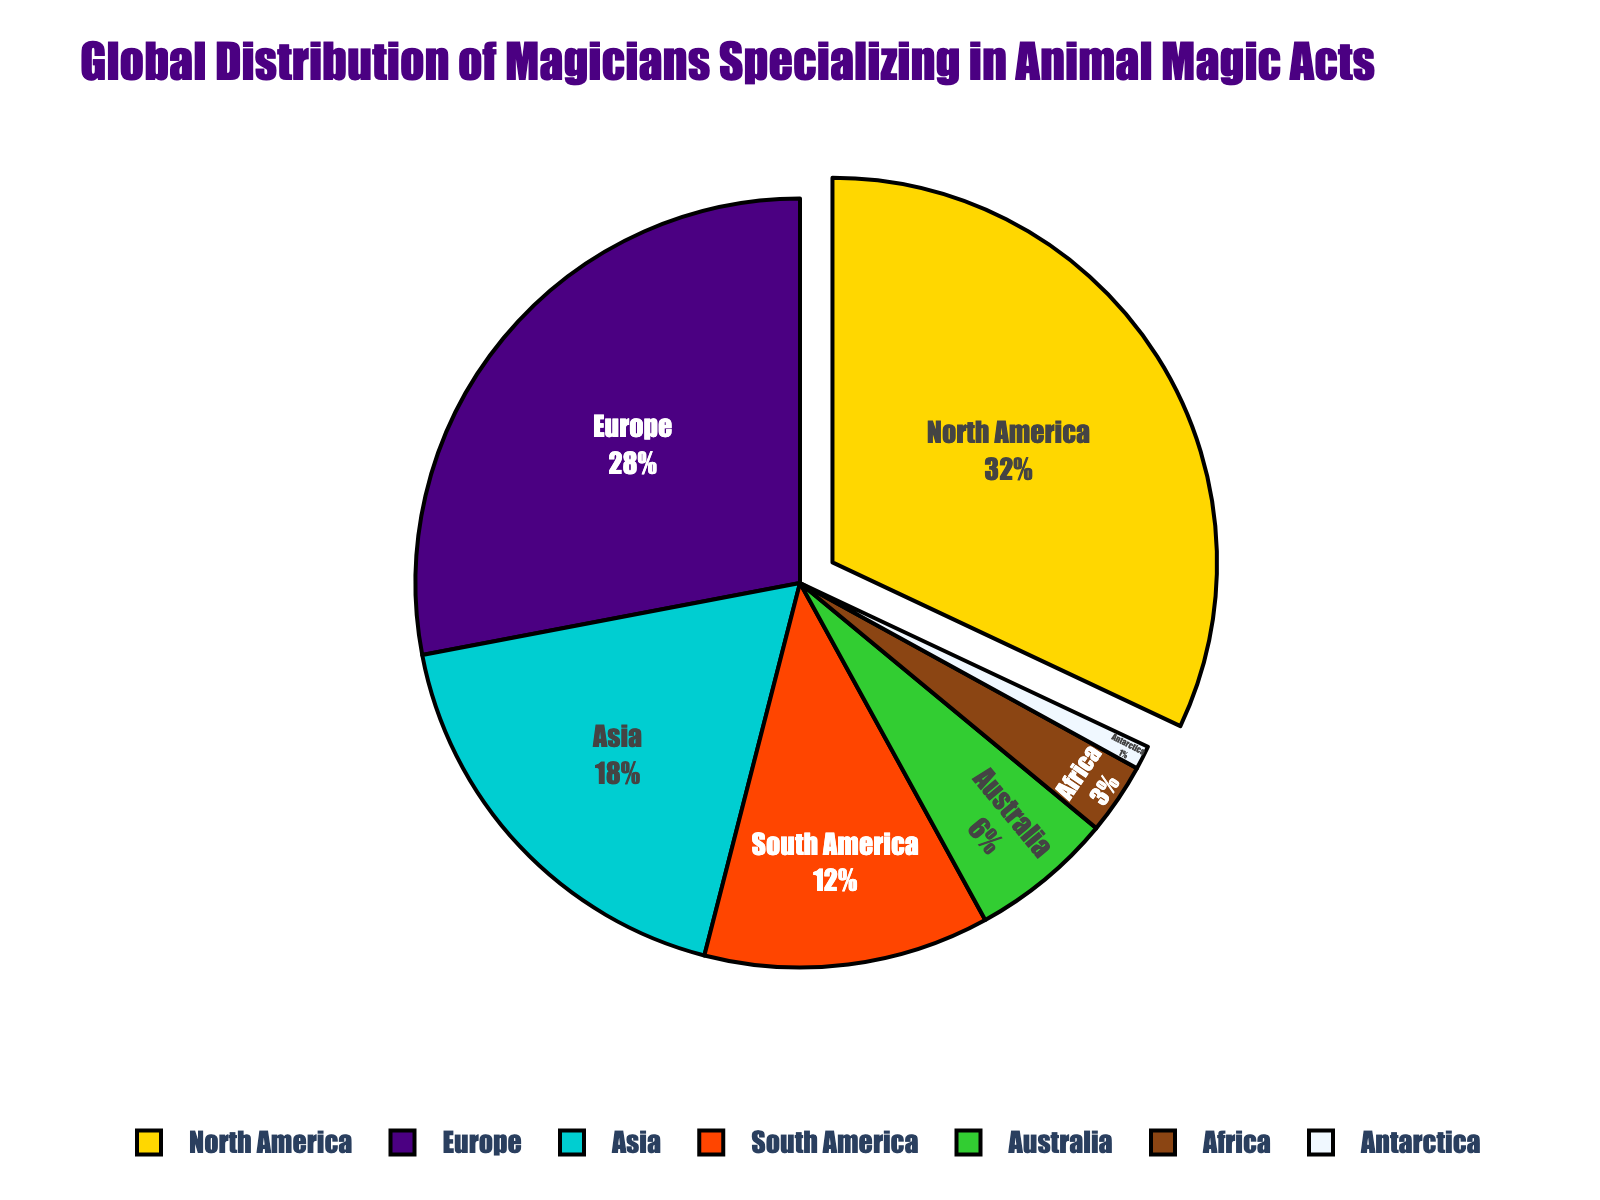Which continent has the highest percentage of magicians specializing in animal magic acts? According to the pie chart, the largest slice corresponds to North America.
Answer: North America What is the combined percentage of magicians specializing in animal magic acts in North America and Europe? To find the combined percentage, add the percentages of North America and Europe: 32% + 28% = 60%.
Answer: 60% Which continents together account for exactly half of the global distribution? We need to find a combination of continents that sum up to 50%. South America (12%) + Asia (18%) + Australia (6%) + Africa (3%) + Antarctica (1%) = 40%, so try another combination. Asia (18%) + Europe (28%) + Antarctica (1%) + Africa (3%) = 50%.
Answer: Asia and Europe What is the percentage difference between Asia and South America in terms of magicians specializing in animal magic acts? Subtract the percentage of South America from that of Asia: 18% - 12% = 6%.
Answer: 6% Identify the continent with the smallest representation of magicians specializing in animal magic acts. The smallest slice on the pie chart represents Antarctica.
Answer: Antarctica How much larger is the percentage of magicians in North America compared to those in Australia? Subtract the percentage of Australia from North America's percentage: 32% - 6% = 26%.
Answer: 26% What percentage of the global distribution is covered by continents with more than 20% representation? Only North America (32%) and Europe (28%) have more than 20%, so their combined percentage is 32% + 28% = 60%.
Answer: 60% How many continents fall below a 10% share in the global distribution? Africa (3%), Australia (6%), and Antarctica (1%) are each below 10%. In total, there are 3 continents.
Answer: 3 Which continent has exactly half the percentage of North America in terms of magicians specializing in animal magic acts? North America is at 32%. Half of this percentage is 16%. Neither Europe (28%) nor Asia (18%) meets this criteria exactly, but Asia (18%) is close.
Answer: Asia (18%) 